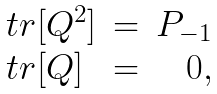<formula> <loc_0><loc_0><loc_500><loc_500>\begin{array} { l c r } t r { [ { Q } ^ { 2 } ] } & = & P _ { - 1 } \\ t r { [ { Q } ] } & = & 0 , \end{array}</formula> 